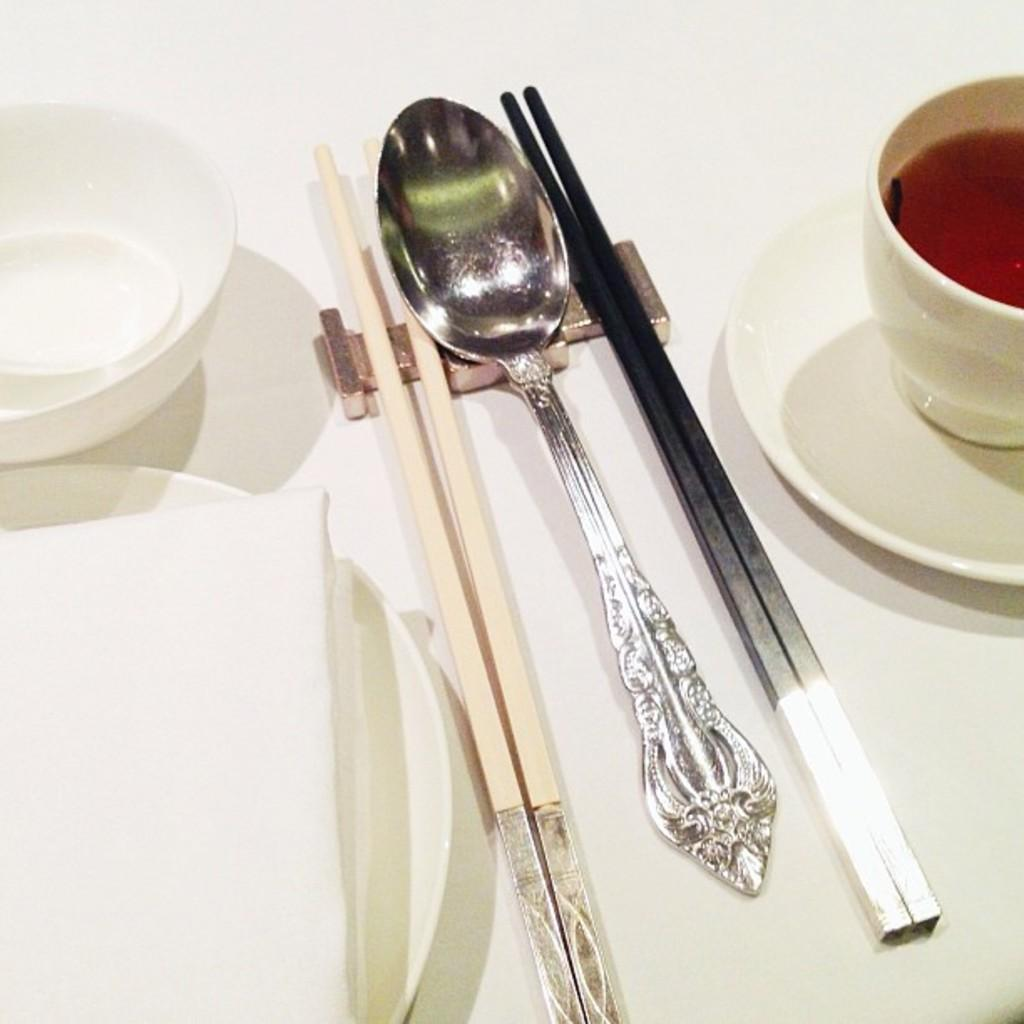What piece of furniture is present in the image? There is a table in the image. What utensils are on the table? There are chopsticks and a spoon on the table. What else is on the table besides utensils? There is a cup on the table. What is inside the cup? The cup contains soup. What type of market is visible in the image? There is no market present in the image; it features a table with utensils and a cup of soup. What day of the week is it in the image? The day of the week cannot be determined from the image, as it only shows a table with utensils and a cup of soup. 